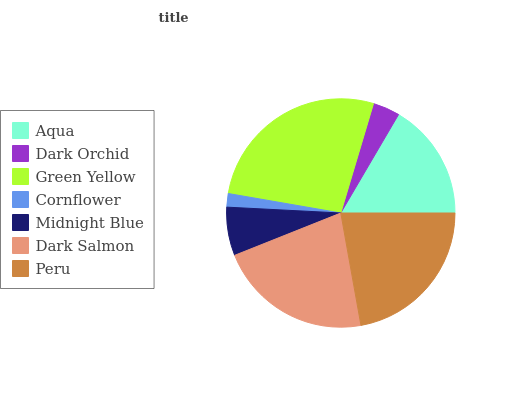Is Cornflower the minimum?
Answer yes or no. Yes. Is Green Yellow the maximum?
Answer yes or no. Yes. Is Dark Orchid the minimum?
Answer yes or no. No. Is Dark Orchid the maximum?
Answer yes or no. No. Is Aqua greater than Dark Orchid?
Answer yes or no. Yes. Is Dark Orchid less than Aqua?
Answer yes or no. Yes. Is Dark Orchid greater than Aqua?
Answer yes or no. No. Is Aqua less than Dark Orchid?
Answer yes or no. No. Is Aqua the high median?
Answer yes or no. Yes. Is Aqua the low median?
Answer yes or no. Yes. Is Cornflower the high median?
Answer yes or no. No. Is Cornflower the low median?
Answer yes or no. No. 